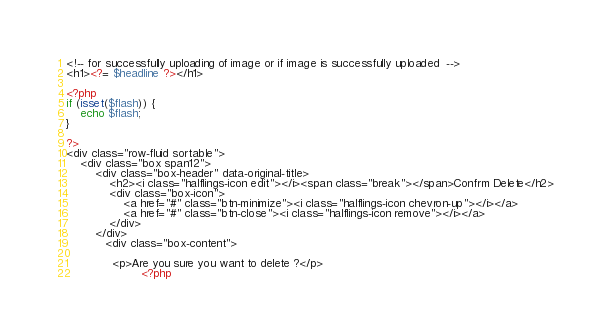Convert code to text. <code><loc_0><loc_0><loc_500><loc_500><_PHP_>
<!-- for successfully uploading of image or if image is successfully uploaded  -->
<h1><?= $headline ?></h1>

<?php  
if (isset($flash)) {
	echo $flash;
}

?>
<div class="row-fluid sortable">
	<div class="box span12">
		<div class="box-header" data-original-title>
			<h2><i class="halflings-icon edit"></i><span class="break"></span>Confrm Delete</h2>
			<div class="box-icon">
				<a href="#" class="btn-minimize"><i class="halflings-icon chevron-up"></i></a>
				<a href="#" class="btn-close"><i class="halflings-icon remove"></i></a>
			</div>
		</div>
		   <div class="box-content">
			   
			 <p>Are you sure you want to delete ?</p>
					 <?php</code> 